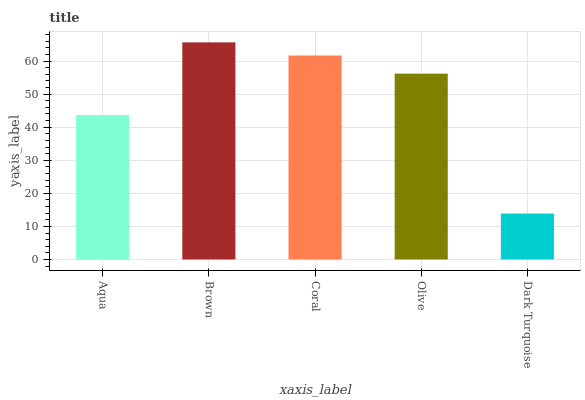Is Dark Turquoise the minimum?
Answer yes or no. Yes. Is Brown the maximum?
Answer yes or no. Yes. Is Coral the minimum?
Answer yes or no. No. Is Coral the maximum?
Answer yes or no. No. Is Brown greater than Coral?
Answer yes or no. Yes. Is Coral less than Brown?
Answer yes or no. Yes. Is Coral greater than Brown?
Answer yes or no. No. Is Brown less than Coral?
Answer yes or no. No. Is Olive the high median?
Answer yes or no. Yes. Is Olive the low median?
Answer yes or no. Yes. Is Aqua the high median?
Answer yes or no. No. Is Dark Turquoise the low median?
Answer yes or no. No. 